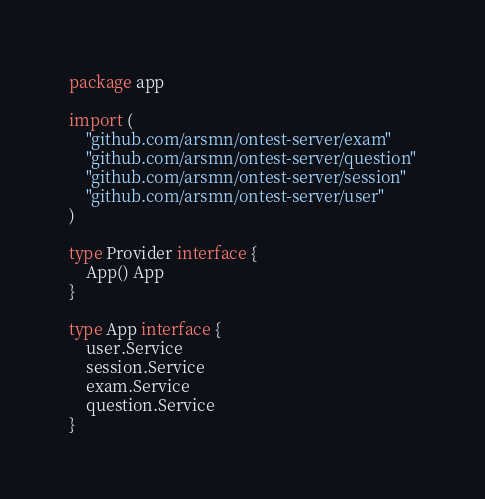<code> <loc_0><loc_0><loc_500><loc_500><_Go_>package app

import (
	"github.com/arsmn/ontest-server/exam"
	"github.com/arsmn/ontest-server/question"
	"github.com/arsmn/ontest-server/session"
	"github.com/arsmn/ontest-server/user"
)

type Provider interface {
	App() App
}

type App interface {
	user.Service
	session.Service
	exam.Service
	question.Service
}
</code> 